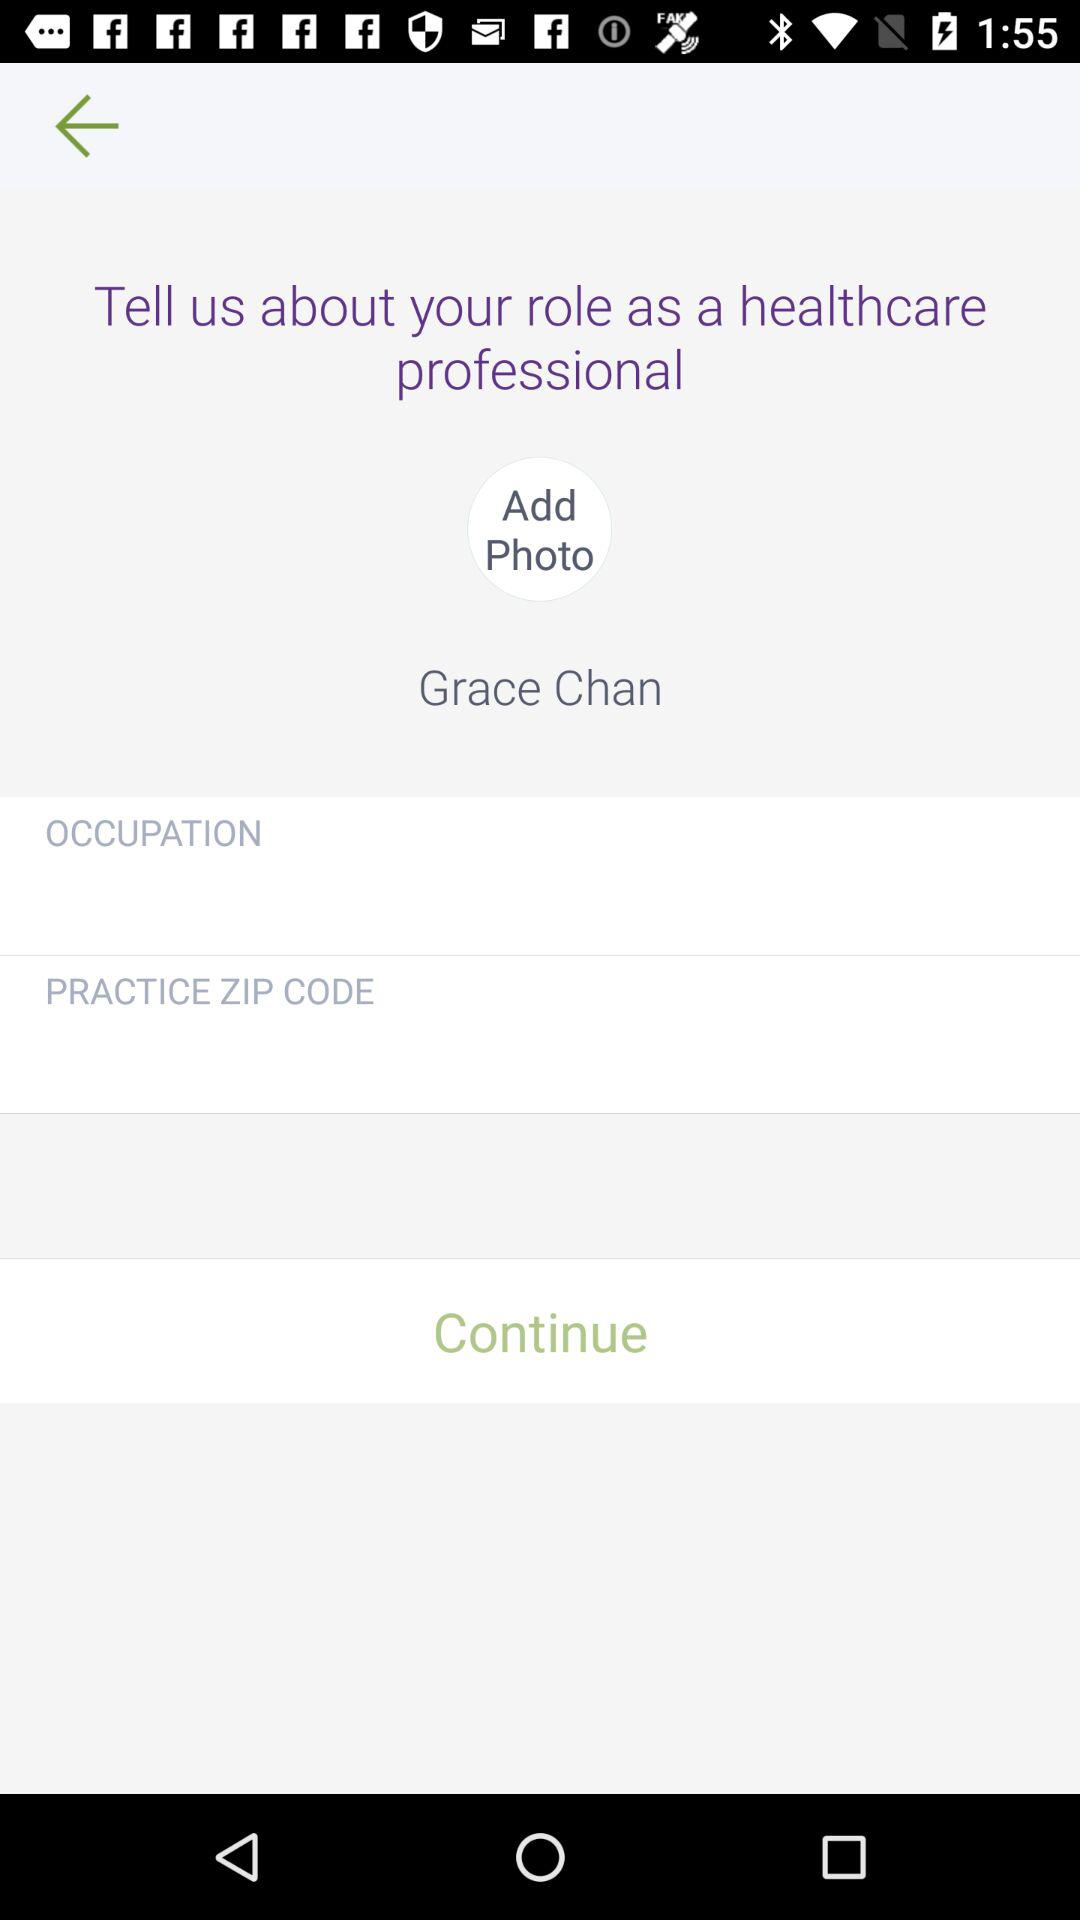What is the name of the person? The name of the person is Grace Chan. 